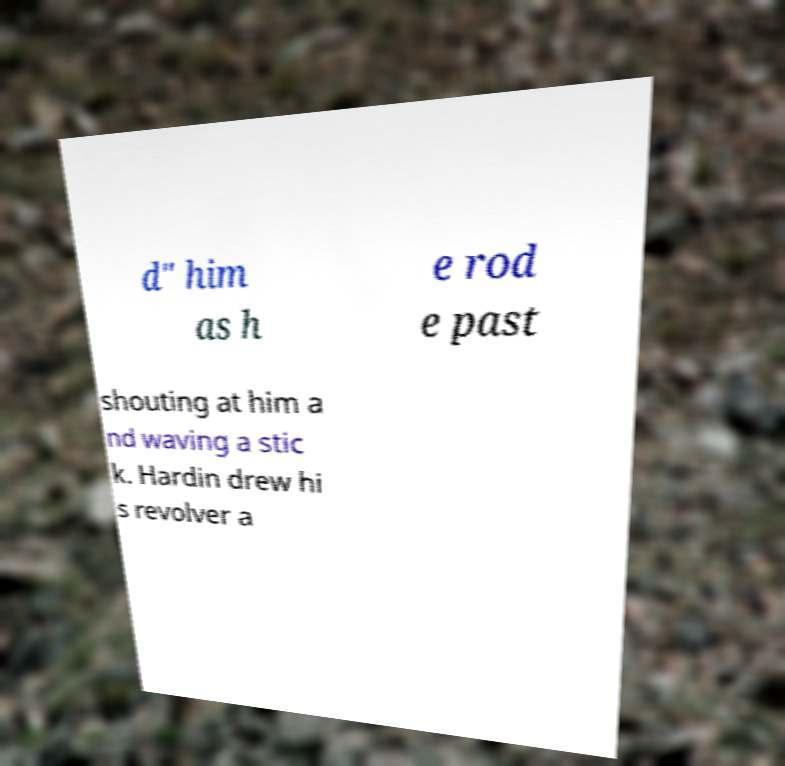Can you accurately transcribe the text from the provided image for me? d" him as h e rod e past shouting at him a nd waving a stic k. Hardin drew hi s revolver a 